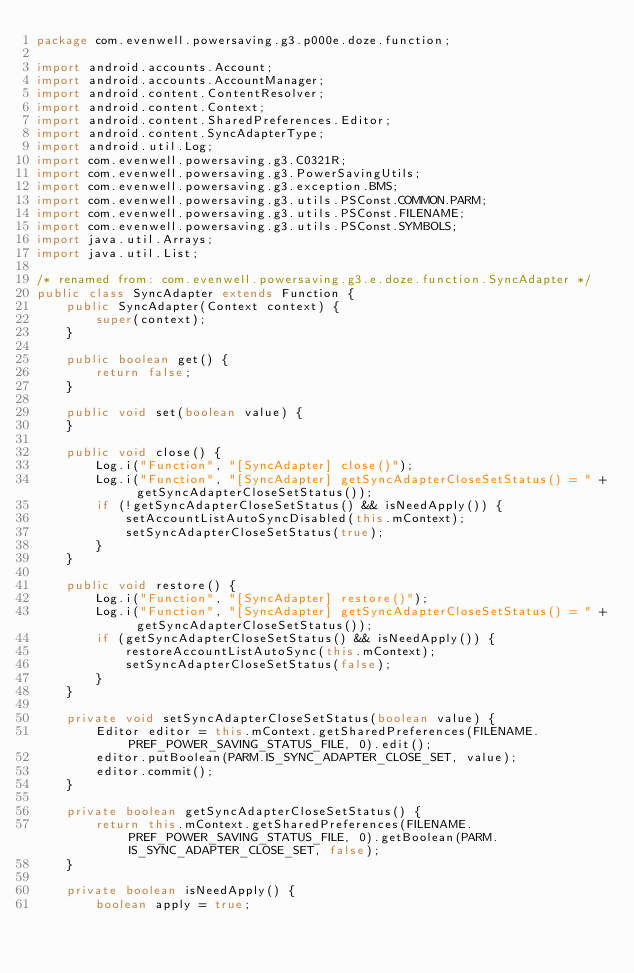<code> <loc_0><loc_0><loc_500><loc_500><_Java_>package com.evenwell.powersaving.g3.p000e.doze.function;

import android.accounts.Account;
import android.accounts.AccountManager;
import android.content.ContentResolver;
import android.content.Context;
import android.content.SharedPreferences.Editor;
import android.content.SyncAdapterType;
import android.util.Log;
import com.evenwell.powersaving.g3.C0321R;
import com.evenwell.powersaving.g3.PowerSavingUtils;
import com.evenwell.powersaving.g3.exception.BMS;
import com.evenwell.powersaving.g3.utils.PSConst.COMMON.PARM;
import com.evenwell.powersaving.g3.utils.PSConst.FILENAME;
import com.evenwell.powersaving.g3.utils.PSConst.SYMBOLS;
import java.util.Arrays;
import java.util.List;

/* renamed from: com.evenwell.powersaving.g3.e.doze.function.SyncAdapter */
public class SyncAdapter extends Function {
    public SyncAdapter(Context context) {
        super(context);
    }

    public boolean get() {
        return false;
    }

    public void set(boolean value) {
    }

    public void close() {
        Log.i("Function", "[SyncAdapter] close()");
        Log.i("Function", "[SyncAdapter] getSyncAdapterCloseSetStatus() = " + getSyncAdapterCloseSetStatus());
        if (!getSyncAdapterCloseSetStatus() && isNeedApply()) {
            setAccountListAutoSyncDisabled(this.mContext);
            setSyncAdapterCloseSetStatus(true);
        }
    }

    public void restore() {
        Log.i("Function", "[SyncAdapter] restore()");
        Log.i("Function", "[SyncAdapter] getSyncAdapterCloseSetStatus() = " + getSyncAdapterCloseSetStatus());
        if (getSyncAdapterCloseSetStatus() && isNeedApply()) {
            restoreAccountListAutoSync(this.mContext);
            setSyncAdapterCloseSetStatus(false);
        }
    }

    private void setSyncAdapterCloseSetStatus(boolean value) {
        Editor editor = this.mContext.getSharedPreferences(FILENAME.PREF_POWER_SAVING_STATUS_FILE, 0).edit();
        editor.putBoolean(PARM.IS_SYNC_ADAPTER_CLOSE_SET, value);
        editor.commit();
    }

    private boolean getSyncAdapterCloseSetStatus() {
        return this.mContext.getSharedPreferences(FILENAME.PREF_POWER_SAVING_STATUS_FILE, 0).getBoolean(PARM.IS_SYNC_ADAPTER_CLOSE_SET, false);
    }

    private boolean isNeedApply() {
        boolean apply = true;</code> 